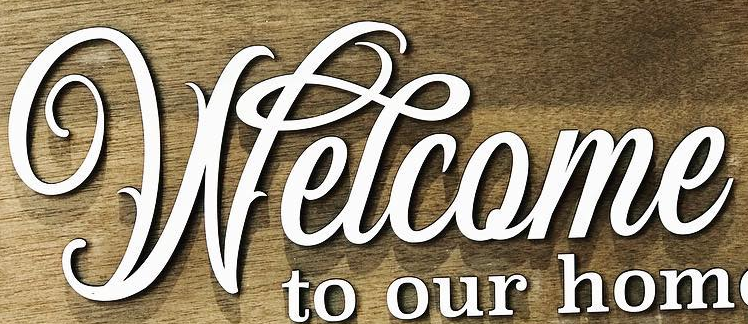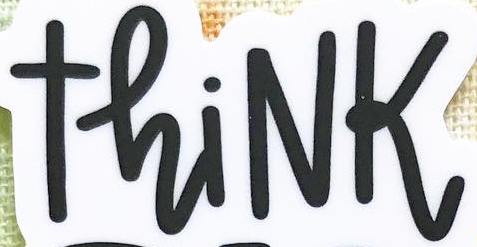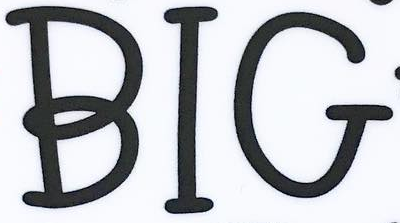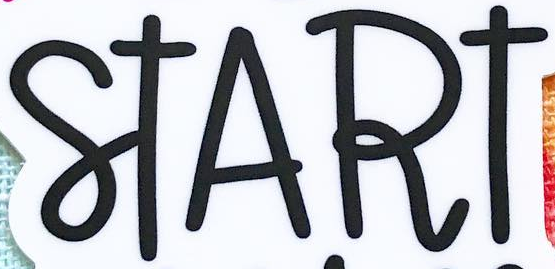Identify the words shown in these images in order, separated by a semicolon. Welcome; ThiNK; BIG; START 